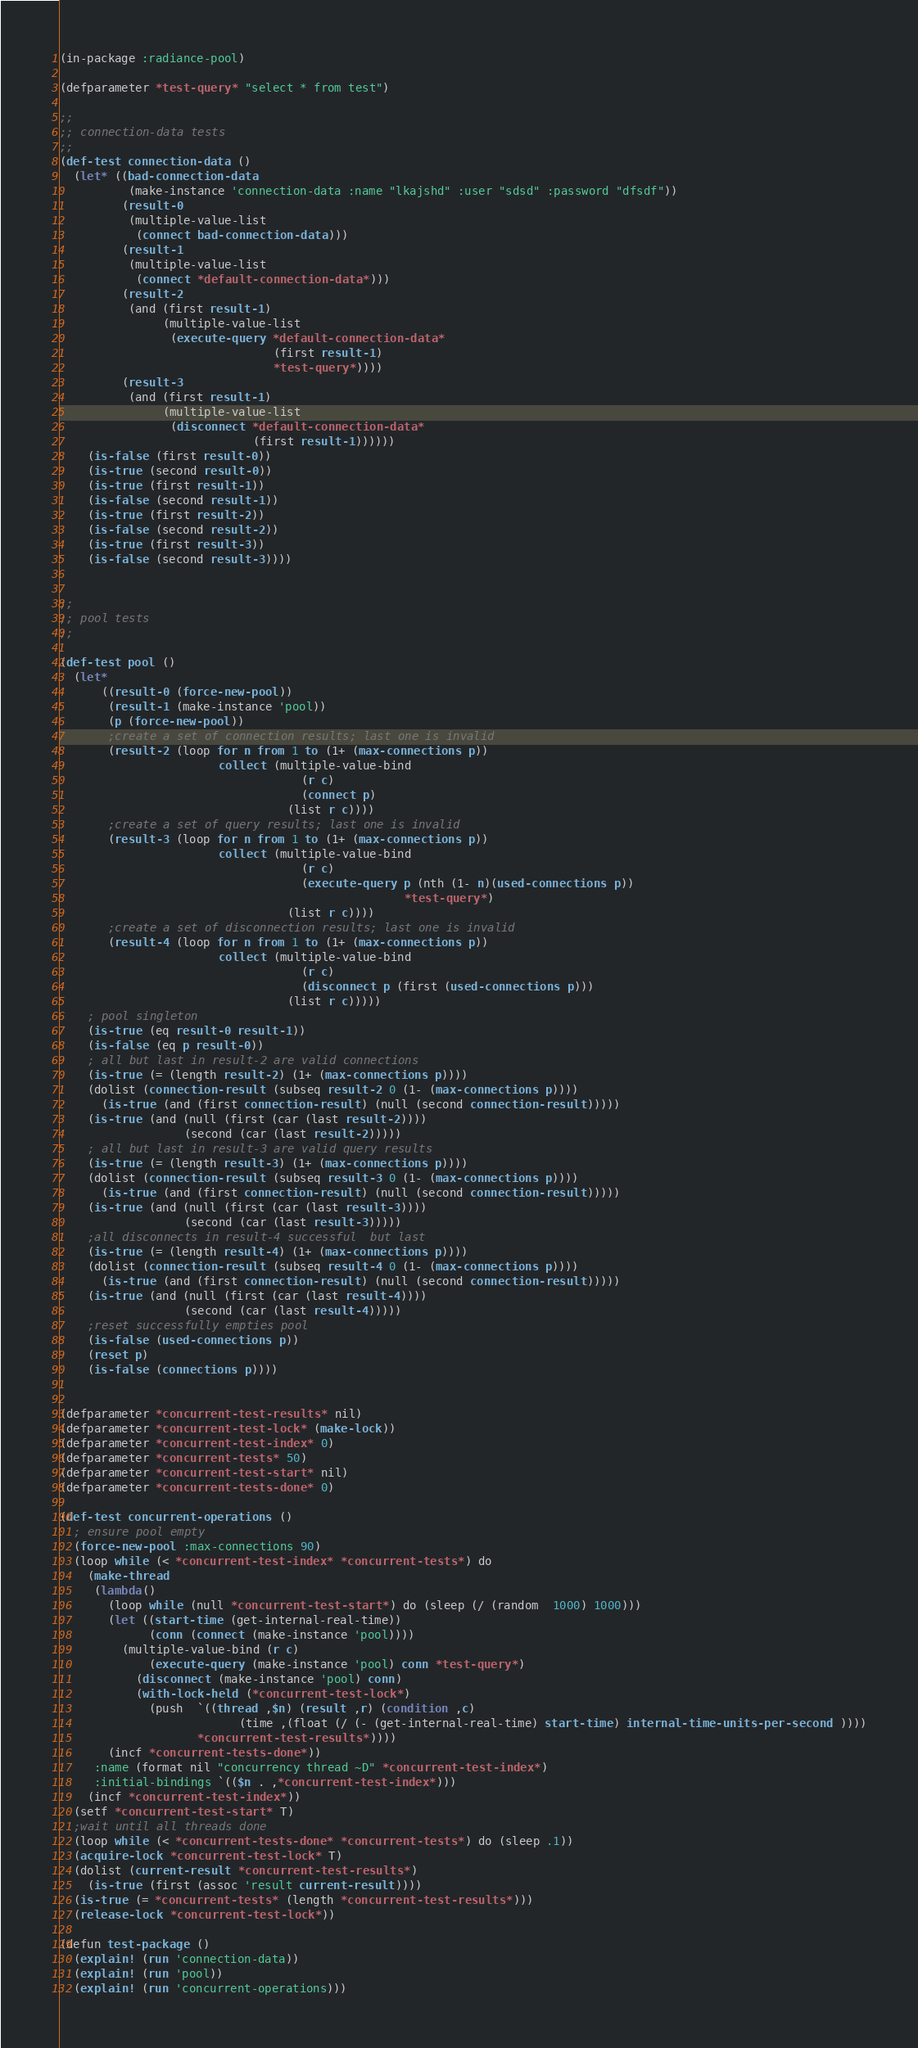Convert code to text. <code><loc_0><loc_0><loc_500><loc_500><_Lisp_>(in-package :radiance-pool)

(defparameter *test-query* "select * from test")

;;
;; connection-data tests
;;
(def-test connection-data ()
  (let* ((bad-connection-data
          (make-instance 'connection-data :name "lkajshd" :user "sdsd" :password "dfsdf"))
         (result-0
          (multiple-value-list
           (connect bad-connection-data)))
         (result-1
          (multiple-value-list
           (connect *default-connection-data*)))
         (result-2
          (and (first result-1)
               (multiple-value-list
                (execute-query *default-connection-data* 
                               (first result-1)
                               *test-query*))))
         (result-3
          (and (first result-1)
               (multiple-value-list
                (disconnect *default-connection-data*
                            (first result-1))))))
    (is-false (first result-0))
    (is-true (second result-0))
    (is-true (first result-1))
    (is-false (second result-1))
    (is-true (first result-2))
    (is-false (second result-2))
    (is-true (first result-3))
    (is-false (second result-3))))


;;
;; pool tests
;;

(def-test pool ()
  (let*
      ((result-0 (force-new-pool))
       (result-1 (make-instance 'pool))
       (p (force-new-pool))
       ;create a set of connection results; last one is invalid
       (result-2 (loop for n from 1 to (1+ (max-connections p))
                       collect (multiple-value-bind 
                                   (r c)
                                   (connect p)
                                 (list r c))))
       ;create a set of query results; last one is invalid
       (result-3 (loop for n from 1 to (1+ (max-connections p))
                       collect (multiple-value-bind 
                                   (r c)
                                   (execute-query p (nth (1- n)(used-connections p))
                                                  *test-query*)
                                 (list r c))))
       ;create a set of disconnection results; last one is invalid
       (result-4 (loop for n from 1 to (1+ (max-connections p))
                       collect (multiple-value-bind 
                                   (r c)
                                   (disconnect p (first (used-connections p)))
                                 (list r c)))))
    ; pool singleton
    (is-true (eq result-0 result-1))
    (is-false (eq p result-0))
    ; all but last in result-2 are valid connections
    (is-true (= (length result-2) (1+ (max-connections p))))
    (dolist (connection-result (subseq result-2 0 (1- (max-connections p))))
      (is-true (and (first connection-result) (null (second connection-result)))))
    (is-true (and (null (first (car (last result-2))))
                  (second (car (last result-2)))))
    ; all but last in result-3 are valid query results
    (is-true (= (length result-3) (1+ (max-connections p))))
    (dolist (connection-result (subseq result-3 0 (1- (max-connections p))))
      (is-true (and (first connection-result) (null (second connection-result)))))
    (is-true (and (null (first (car (last result-3))))
                  (second (car (last result-3)))))
    ;all disconnects in result-4 successful  but last
    (is-true (= (length result-4) (1+ (max-connections p))))
    (dolist (connection-result (subseq result-4 0 (1- (max-connections p))))
      (is-true (and (first connection-result) (null (second connection-result)))))
    (is-true (and (null (first (car (last result-4))))
                  (second (car (last result-4)))))
    ;reset successfully empties pool
    (is-false (used-connections p))
    (reset p)
    (is-false (connections p))))

 
(defparameter *concurrent-test-results* nil)
(defparameter *concurrent-test-lock* (make-lock))
(defparameter *concurrent-test-index* 0)
(defparameter *concurrent-tests* 50)
(defparameter *concurrent-test-start* nil)
(defparameter *concurrent-tests-done* 0)

(def-test concurrent-operations ()
  ; ensure pool empty
  (force-new-pool :max-connections 90)
  (loop while (< *concurrent-test-index* *concurrent-tests*) do
    (make-thread 
     (lambda() 
       (loop while (null *concurrent-test-start*) do (sleep (/ (random  1000) 1000)))
       (let ((start-time (get-internal-real-time))
             (conn (connect (make-instance 'pool))))
         (multiple-value-bind (r c)
             (execute-query (make-instance 'pool) conn *test-query*)
           (disconnect (make-instance 'pool) conn)
           (with-lock-held (*concurrent-test-lock*)
             (push  `((thread ,$n) (result ,r) (condition ,c) 
                          (time ,(float (/ (- (get-internal-real-time) start-time) internal-time-units-per-second ))))
                    *concurrent-test-results*))))
       (incf *concurrent-tests-done*))
     :name (format nil "concurrency thread ~D" *concurrent-test-index*) 
     :initial-bindings `(($n . ,*concurrent-test-index*)))
    (incf *concurrent-test-index*))
  (setf *concurrent-test-start* T)
  ;wait until all threads done
  (loop while (< *concurrent-tests-done* *concurrent-tests*) do (sleep .1))
  (acquire-lock *concurrent-test-lock* T)
  (dolist (current-result *concurrent-test-results*)
    (is-true (first (assoc 'result current-result))))
  (is-true (= *concurrent-tests* (length *concurrent-test-results*)))
  (release-lock *concurrent-test-lock*))

(defun test-package ()
  (explain! (run 'connection-data))
  (explain! (run 'pool))
  (explain! (run 'concurrent-operations)))

</code> 